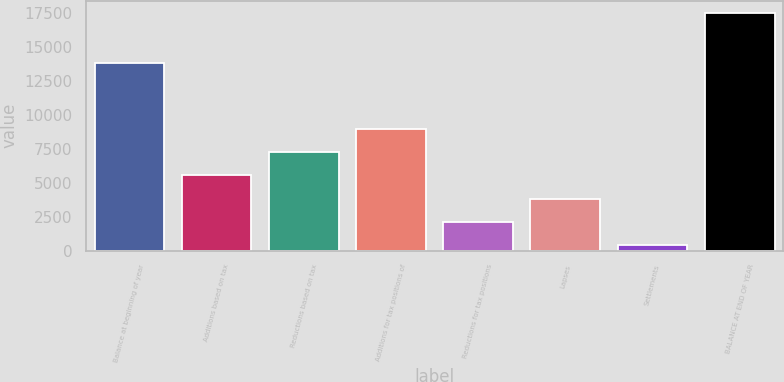Convert chart. <chart><loc_0><loc_0><loc_500><loc_500><bar_chart><fcel>Balance at beginning of year<fcel>Additions based on tax<fcel>Reductions based on tax<fcel>Additions for tax positions of<fcel>Reductions for tax positions<fcel>Lapses<fcel>Settlements<fcel>BALANCE AT END OF YEAR<nl><fcel>13844<fcel>5544.2<fcel>7255.6<fcel>8967<fcel>2121.4<fcel>3832.8<fcel>410<fcel>17524<nl></chart> 